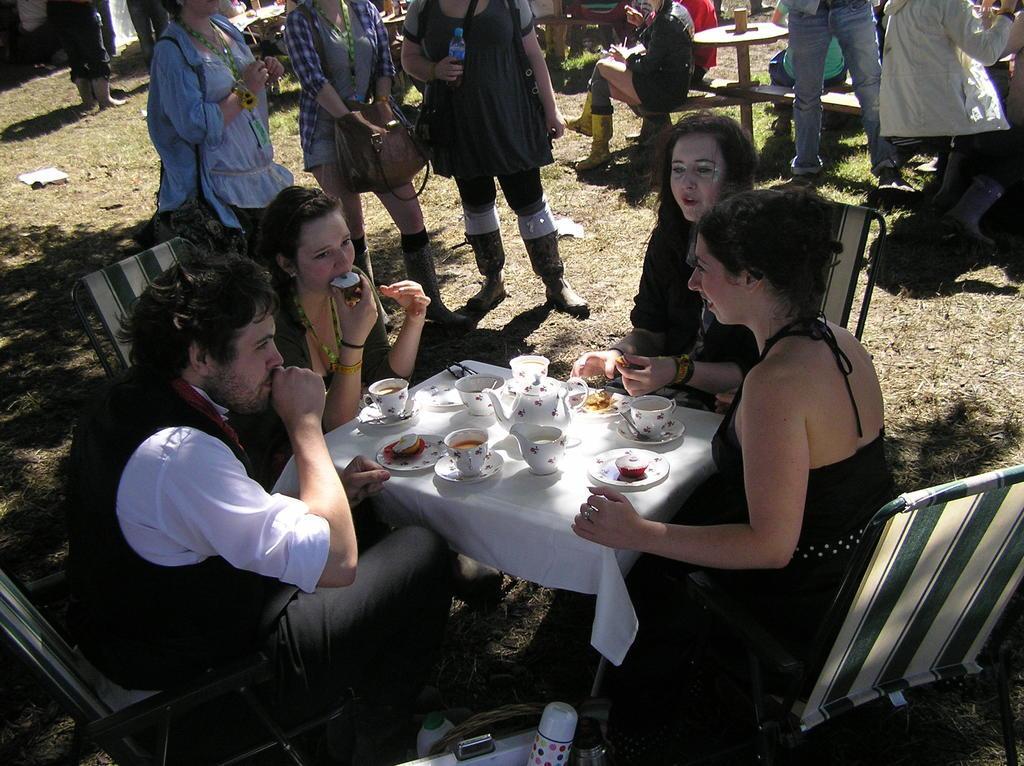In one or two sentences, can you explain what this image depicts? This picture describe about a group of girls and boys who is celebrating the tea party outside of the playing ground we can see a table on which white cloth is placed and small cup cakes and tea cup. And this girl is eating the cake and behind there are three girls standing with the brown bag, opposite to them there is another girl who is sitting on the bench wearing a golden color boots and a man standing beside her wearing blue jean. 